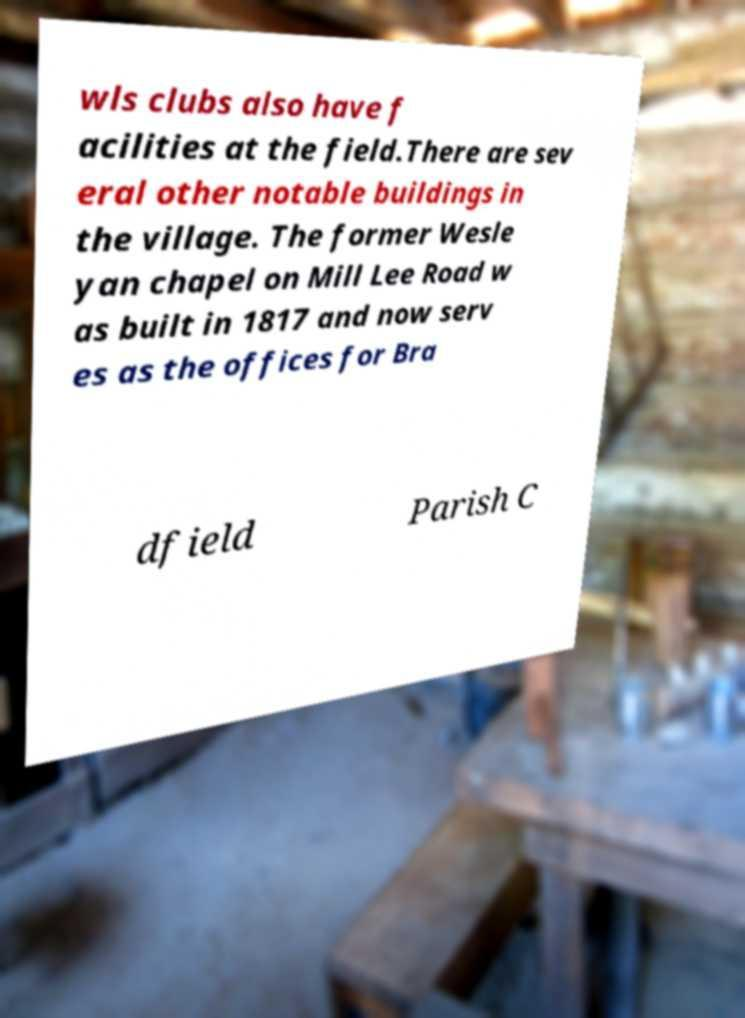Could you extract and type out the text from this image? wls clubs also have f acilities at the field.There are sev eral other notable buildings in the village. The former Wesle yan chapel on Mill Lee Road w as built in 1817 and now serv es as the offices for Bra dfield Parish C 